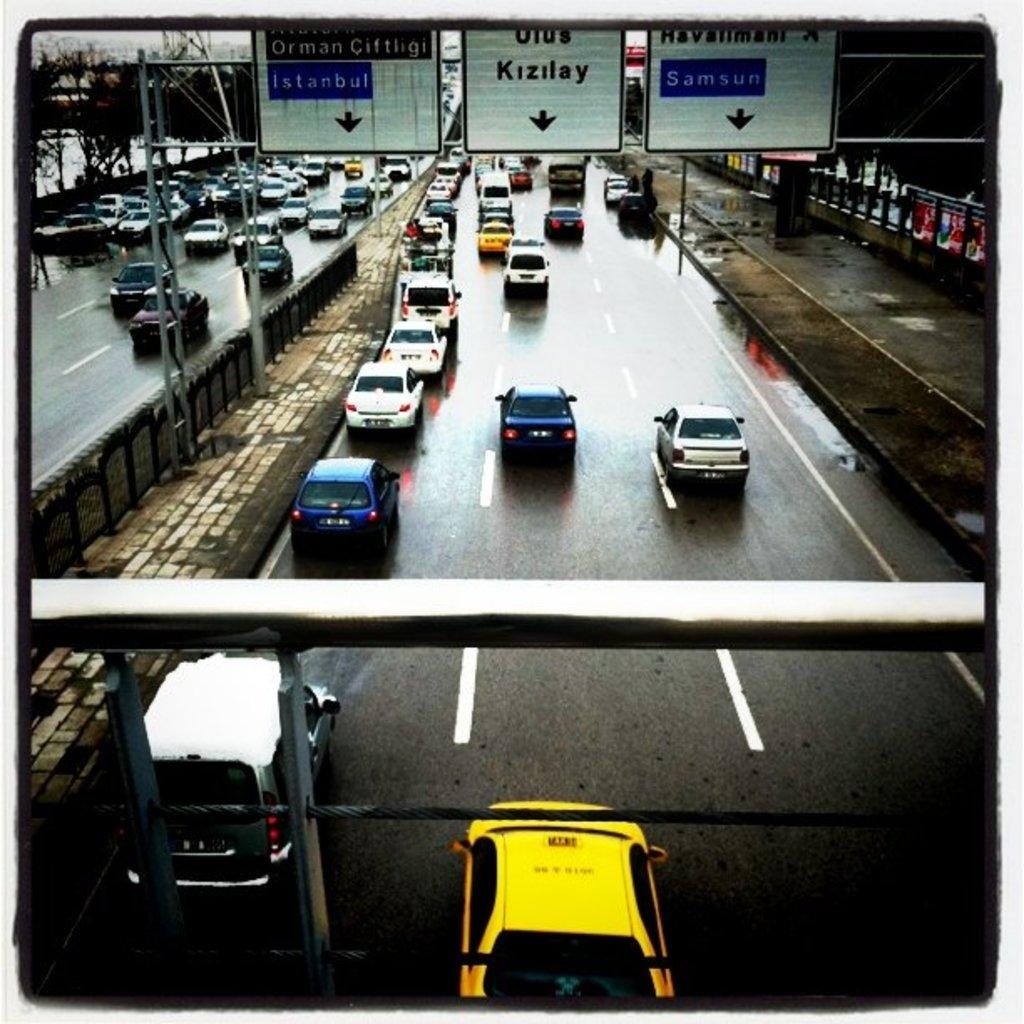Provide a one-sentence caption for the provided image. overhead highway signs directing to Istanbul, Kizilay and Samsun. 